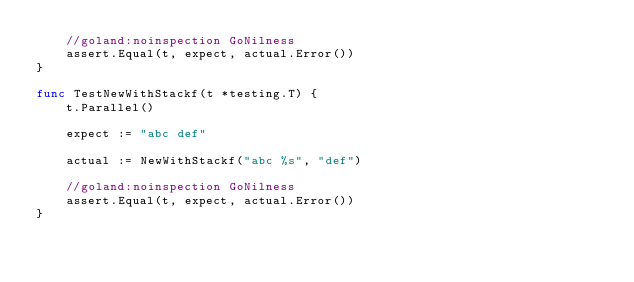Convert code to text. <code><loc_0><loc_0><loc_500><loc_500><_Go_>	//goland:noinspection GoNilness
	assert.Equal(t, expect, actual.Error())
}

func TestNewWithStackf(t *testing.T) {
	t.Parallel()

	expect := "abc def"

	actual := NewWithStackf("abc %s", "def")

	//goland:noinspection GoNilness
	assert.Equal(t, expect, actual.Error())
}
</code> 